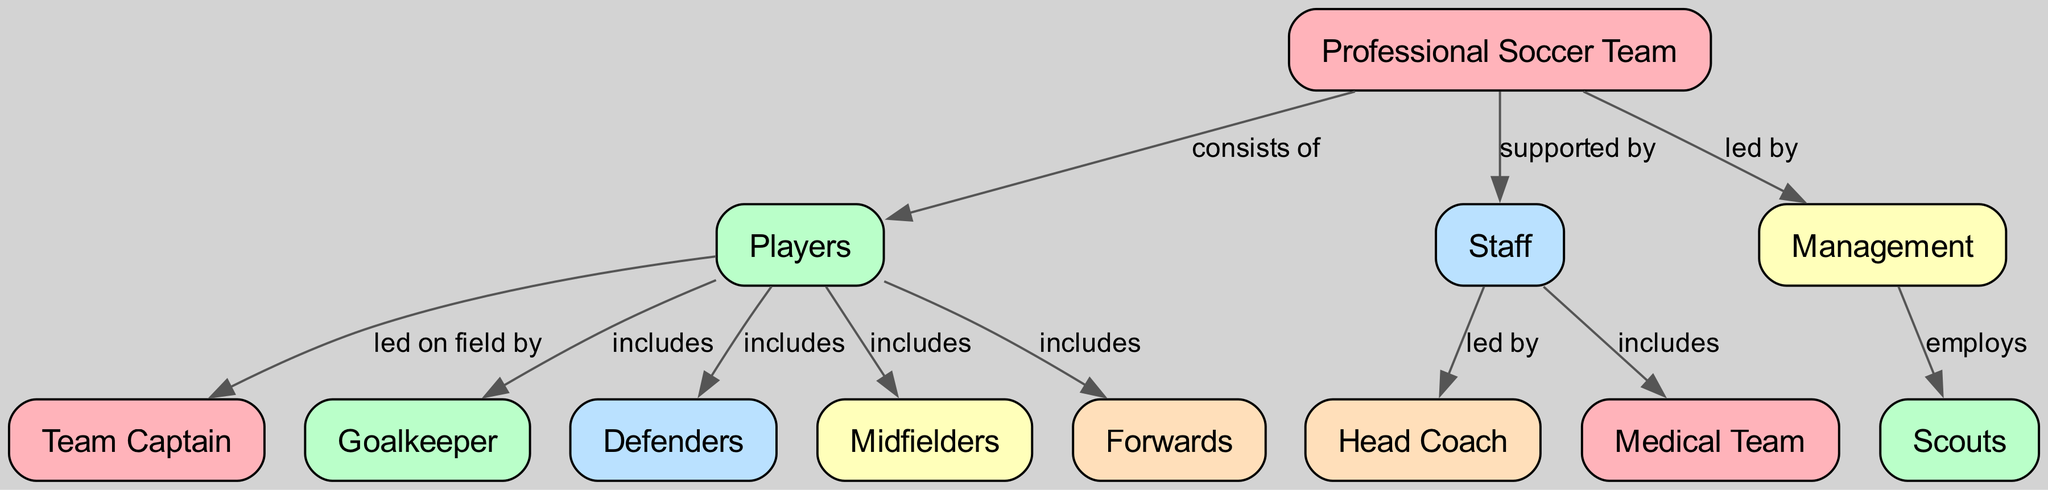What are the main components of a professional soccer team? The diagram highlights three main components: players, staff, and management. Each component plays a distinct role in the structure of the team.
Answer: players, staff, management Who leads the team on the field? According to the diagram, the Team Captain is responsible for leading the players on the field.
Answer: Team Captain How many types of players are included in the team? The diagram specifies four types of players: goalkeeper, defenders, midfielders, and forwards. By counting these, we find there are four types.
Answer: 4 What does the management employ? The management is depicted as employing scouts according to the relationships in the diagram.
Answer: scouts Who is the head of the staff? The diagram indicates that the staff is led by the Head Coach. This relationship is clearly defined between these nodes.
Answer: Head Coach What is the role of the medical team in the structure? In the diagram, the medical team is included as part of the staff, implying their role in supporting the players' health and fitness.
Answer: included How many edges are in the diagram? By reviewing the connections between nodes, the diagram shows a total of ten edges representing the various relationships.
Answer: 10 Which group is supported by the players? The diagram illustrates that players support the Team Captain on the field, signaling a direct relationship.
Answer: Team Captain What is the relationship between players and the goalkeeper? The diagram states that players include the goalkeeper, showing that the goalkeeper is part of the overall player composition.
Answer: includes 